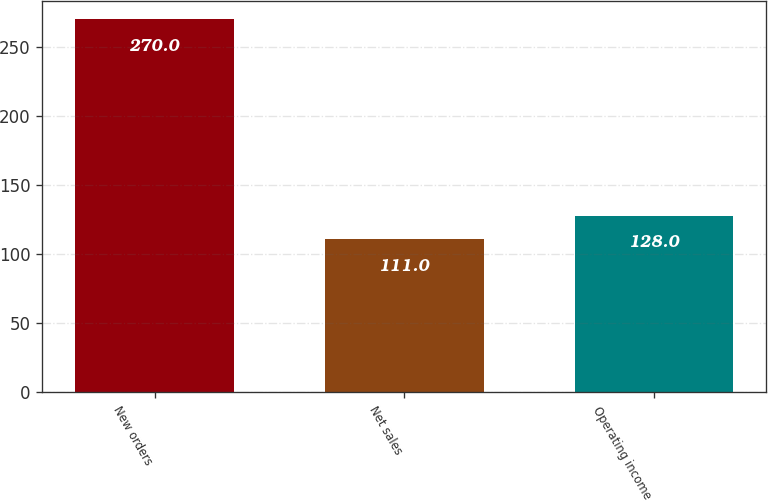<chart> <loc_0><loc_0><loc_500><loc_500><bar_chart><fcel>New orders<fcel>Net sales<fcel>Operating income<nl><fcel>270<fcel>111<fcel>128<nl></chart> 